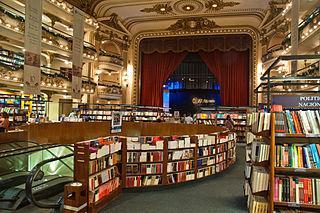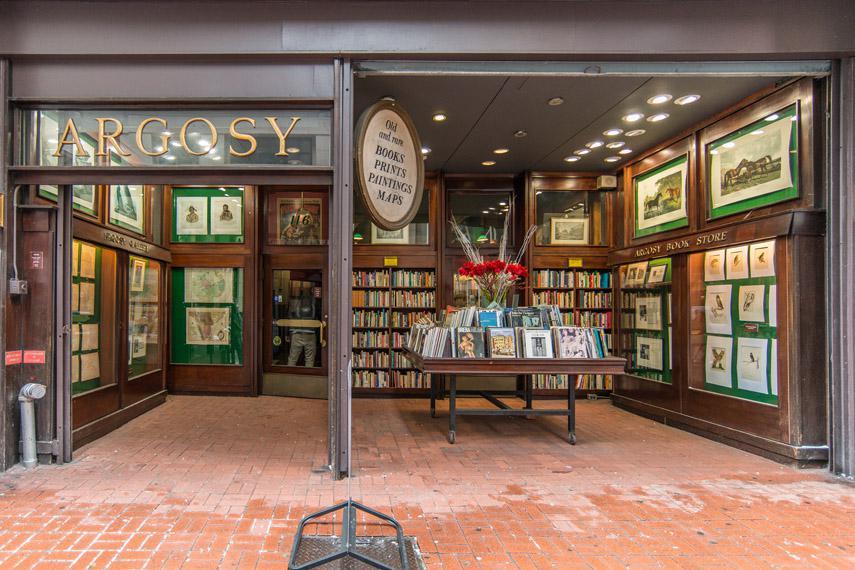The first image is the image on the left, the second image is the image on the right. Considering the images on both sides, is "The right image includes green reading lamps suspended from black arches." valid? Answer yes or no. No. 